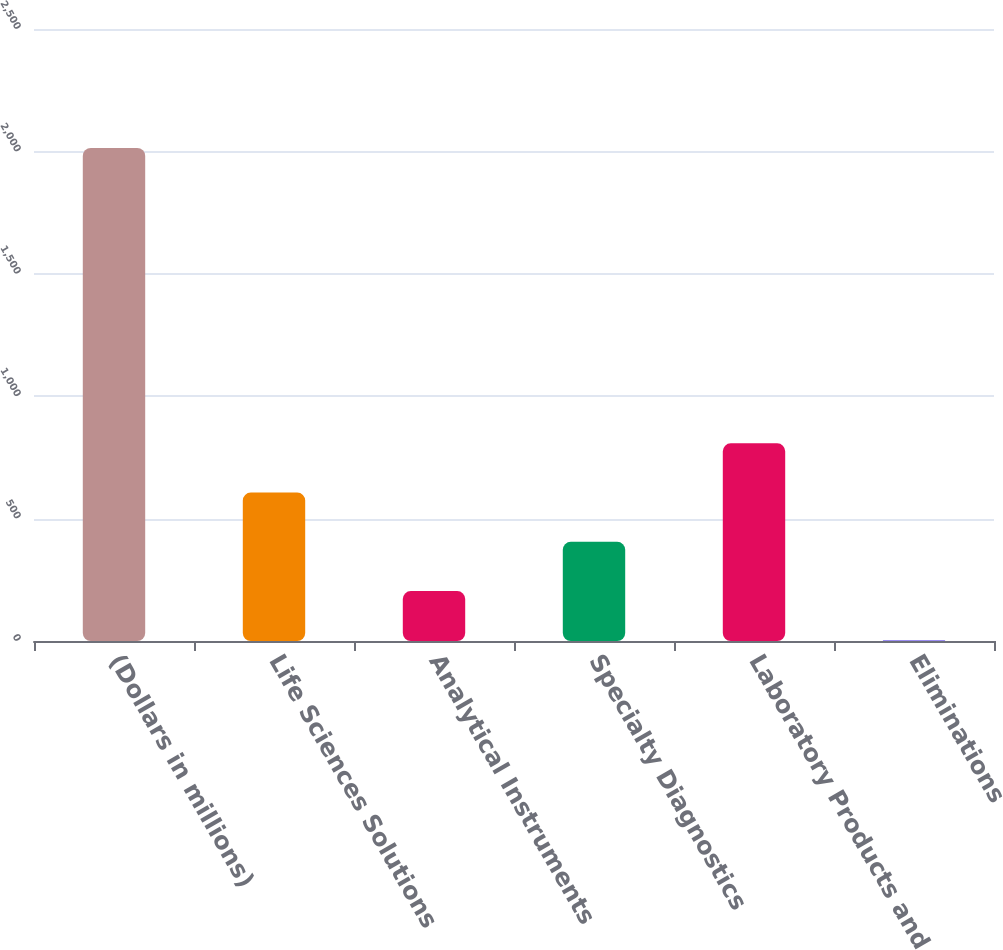Convert chart. <chart><loc_0><loc_0><loc_500><loc_500><bar_chart><fcel>(Dollars in millions)<fcel>Life Sciences Solutions<fcel>Analytical Instruments<fcel>Specialty Diagnostics<fcel>Laboratory Products and<fcel>Eliminations<nl><fcel>2014<fcel>606.3<fcel>204.1<fcel>405.2<fcel>807.4<fcel>3<nl></chart> 